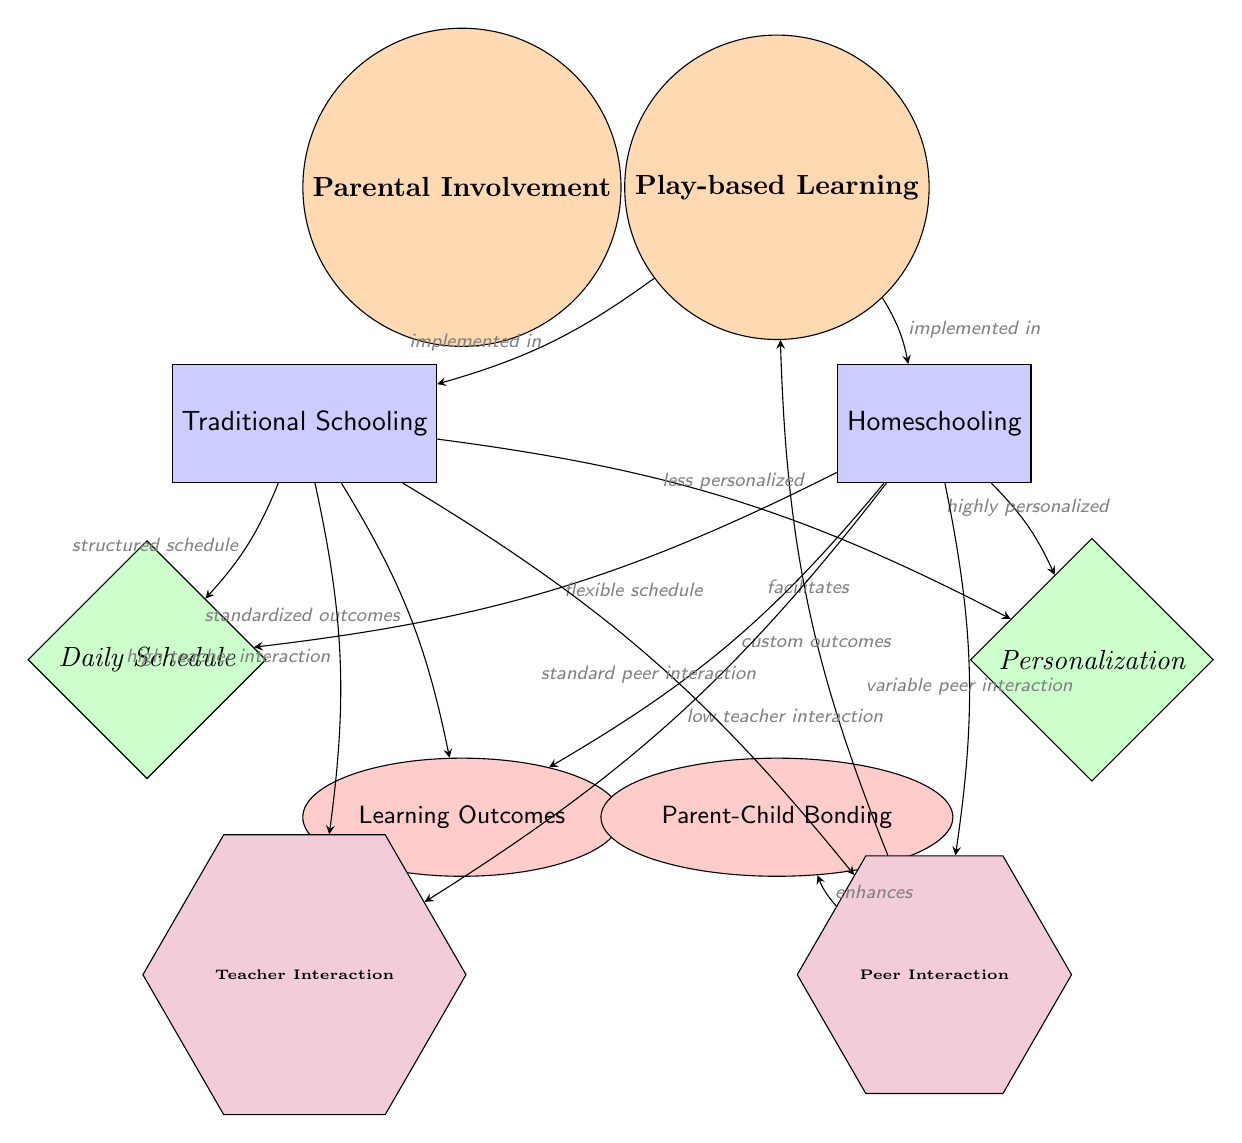What are the two main categories discussed in the diagram? The diagram identifies "Traditional Schooling" and "Homeschooling" as the two main categories, visually represented by separate nodes labeled as such.
Answer: Traditional Schooling, Homeschooling How many factors are represented in the diagram? There are two factors listed in the diagram: "Daily Schedule" and "Personalization." These are shown as diamond-shaped nodes below the category nodes.
Answer: 2 What is the relationship between "Parental Involvement" and "Play-based Learning"? The edge connecting these two central nodes indicates that "Parental Involvement" facilitates "Play-based Learning," highlighting the supportive role parents play in this educational approach.
Answer: facilitates Which category has a flexible schedule according to the diagram? The arrow stemming from "Homeschooling" pointing to the "Daily Schedule" factor specifies that it operates on a flexible schedule, contrasting it with Traditional Schooling.
Answer: Homeschooling What type of outcomes does Traditional Schooling aim for according to the diagram? The connection from "Traditional Schooling" to "Learning Outcomes" indicates that it aims for standardized outcomes, which are less personalized compared to those in homeschooling.
Answer: standardized outcomes What kind of parental interaction is enhanced by the implementation of Play-based Learning? According to the diagram, "Parental Involvement" enhances "Parent-Child Bonding," indicating the positive effects of parental engagement in play-based educational activities.
Answer: enhances How does the level of teacher interaction differ between Traditional Schooling and Homeschooling? The diagram illustrates that Traditional Schooling has "high teacher interaction," while Homeschooling has "low teacher interaction," highlighting a disparity in engagement with teachers.
Answer: high, low What specific interaction is affected by peer relationships in Traditional Schooling? The connection from "Traditional Schooling" to "Peer Interaction" states that it results in standard peer interaction, denoting a common mode of social engagement in that setting.
Answer: standard peer interaction What is the expected outcome for Homeschooling as per the diagram? The diagram shows that Homeschooling has "custom outcomes," which are tailored to individual children's needs as opposed to a one-size-fits-all approach typically seen in traditional settings.
Answer: custom outcomes 